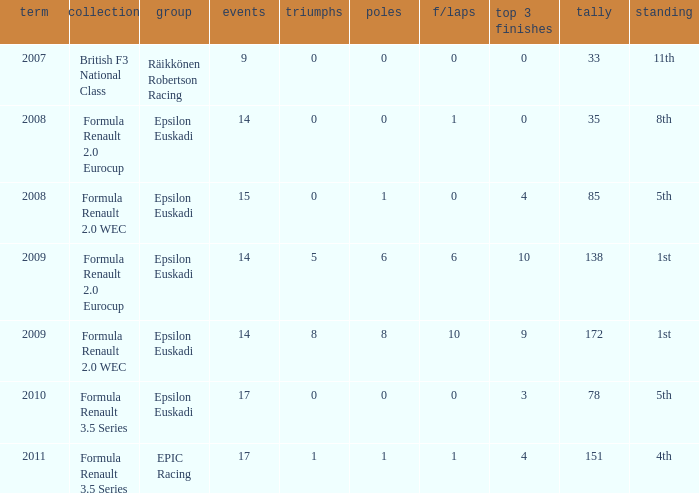What team was he on when he had 10 f/laps? Epsilon Euskadi. 